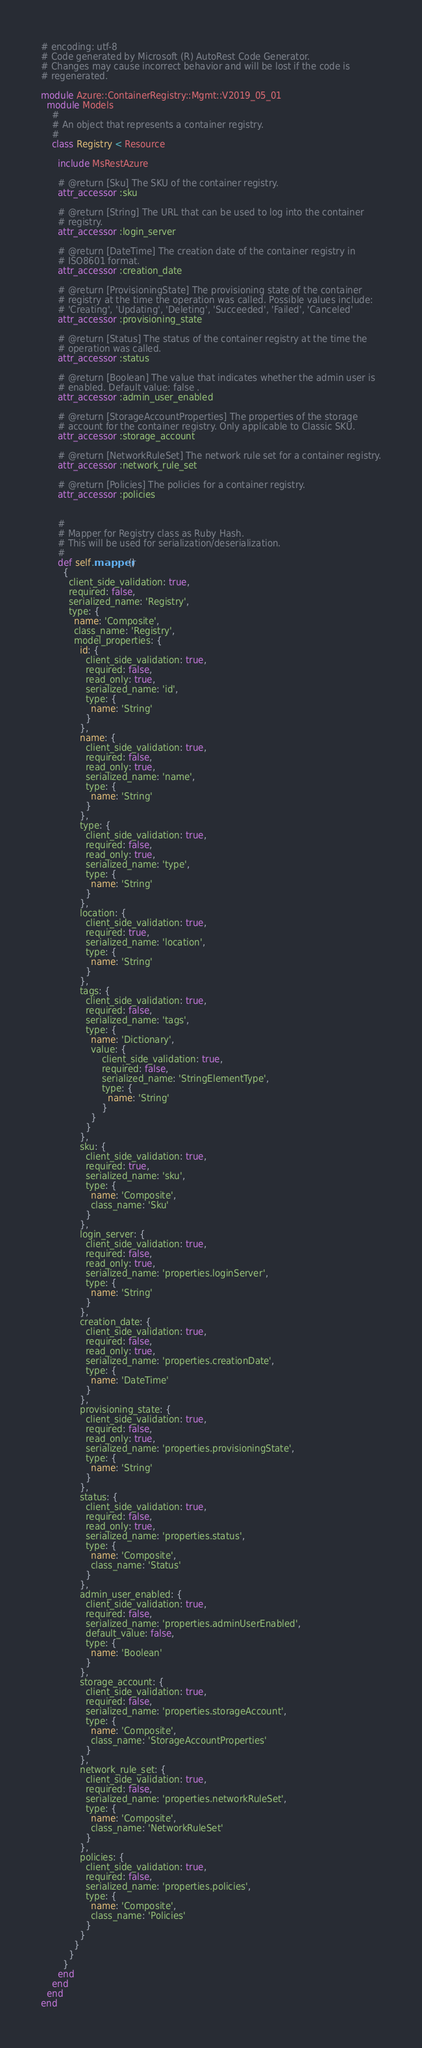<code> <loc_0><loc_0><loc_500><loc_500><_Ruby_># encoding: utf-8
# Code generated by Microsoft (R) AutoRest Code Generator.
# Changes may cause incorrect behavior and will be lost if the code is
# regenerated.

module Azure::ContainerRegistry::Mgmt::V2019_05_01
  module Models
    #
    # An object that represents a container registry.
    #
    class Registry < Resource

      include MsRestAzure

      # @return [Sku] The SKU of the container registry.
      attr_accessor :sku

      # @return [String] The URL that can be used to log into the container
      # registry.
      attr_accessor :login_server

      # @return [DateTime] The creation date of the container registry in
      # ISO8601 format.
      attr_accessor :creation_date

      # @return [ProvisioningState] The provisioning state of the container
      # registry at the time the operation was called. Possible values include:
      # 'Creating', 'Updating', 'Deleting', 'Succeeded', 'Failed', 'Canceled'
      attr_accessor :provisioning_state

      # @return [Status] The status of the container registry at the time the
      # operation was called.
      attr_accessor :status

      # @return [Boolean] The value that indicates whether the admin user is
      # enabled. Default value: false .
      attr_accessor :admin_user_enabled

      # @return [StorageAccountProperties] The properties of the storage
      # account for the container registry. Only applicable to Classic SKU.
      attr_accessor :storage_account

      # @return [NetworkRuleSet] The network rule set for a container registry.
      attr_accessor :network_rule_set

      # @return [Policies] The policies for a container registry.
      attr_accessor :policies


      #
      # Mapper for Registry class as Ruby Hash.
      # This will be used for serialization/deserialization.
      #
      def self.mapper()
        {
          client_side_validation: true,
          required: false,
          serialized_name: 'Registry',
          type: {
            name: 'Composite',
            class_name: 'Registry',
            model_properties: {
              id: {
                client_side_validation: true,
                required: false,
                read_only: true,
                serialized_name: 'id',
                type: {
                  name: 'String'
                }
              },
              name: {
                client_side_validation: true,
                required: false,
                read_only: true,
                serialized_name: 'name',
                type: {
                  name: 'String'
                }
              },
              type: {
                client_side_validation: true,
                required: false,
                read_only: true,
                serialized_name: 'type',
                type: {
                  name: 'String'
                }
              },
              location: {
                client_side_validation: true,
                required: true,
                serialized_name: 'location',
                type: {
                  name: 'String'
                }
              },
              tags: {
                client_side_validation: true,
                required: false,
                serialized_name: 'tags',
                type: {
                  name: 'Dictionary',
                  value: {
                      client_side_validation: true,
                      required: false,
                      serialized_name: 'StringElementType',
                      type: {
                        name: 'String'
                      }
                  }
                }
              },
              sku: {
                client_side_validation: true,
                required: true,
                serialized_name: 'sku',
                type: {
                  name: 'Composite',
                  class_name: 'Sku'
                }
              },
              login_server: {
                client_side_validation: true,
                required: false,
                read_only: true,
                serialized_name: 'properties.loginServer',
                type: {
                  name: 'String'
                }
              },
              creation_date: {
                client_side_validation: true,
                required: false,
                read_only: true,
                serialized_name: 'properties.creationDate',
                type: {
                  name: 'DateTime'
                }
              },
              provisioning_state: {
                client_side_validation: true,
                required: false,
                read_only: true,
                serialized_name: 'properties.provisioningState',
                type: {
                  name: 'String'
                }
              },
              status: {
                client_side_validation: true,
                required: false,
                read_only: true,
                serialized_name: 'properties.status',
                type: {
                  name: 'Composite',
                  class_name: 'Status'
                }
              },
              admin_user_enabled: {
                client_side_validation: true,
                required: false,
                serialized_name: 'properties.adminUserEnabled',
                default_value: false,
                type: {
                  name: 'Boolean'
                }
              },
              storage_account: {
                client_side_validation: true,
                required: false,
                serialized_name: 'properties.storageAccount',
                type: {
                  name: 'Composite',
                  class_name: 'StorageAccountProperties'
                }
              },
              network_rule_set: {
                client_side_validation: true,
                required: false,
                serialized_name: 'properties.networkRuleSet',
                type: {
                  name: 'Composite',
                  class_name: 'NetworkRuleSet'
                }
              },
              policies: {
                client_side_validation: true,
                required: false,
                serialized_name: 'properties.policies',
                type: {
                  name: 'Composite',
                  class_name: 'Policies'
                }
              }
            }
          }
        }
      end
    end
  end
end
</code> 